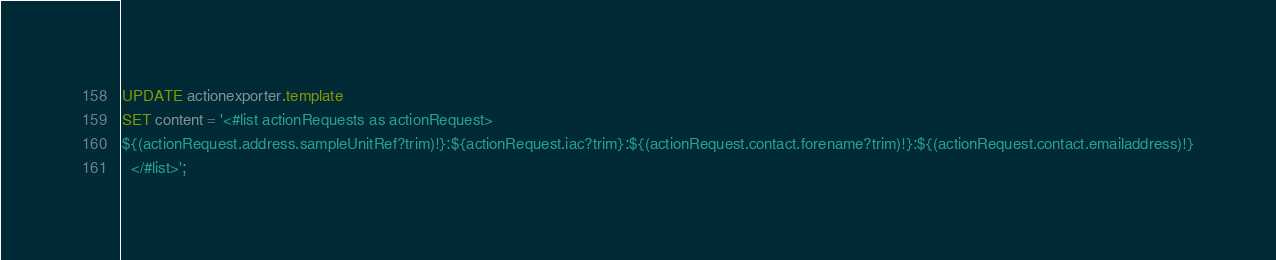Convert code to text. <code><loc_0><loc_0><loc_500><loc_500><_SQL_>UPDATE actionexporter.template
SET content = '<#list actionRequests as actionRequest>
${(actionRequest.address.sampleUnitRef?trim)!}:${actionRequest.iac?trim}:${(actionRequest.contact.forename?trim)!}:${(actionRequest.contact.emailaddress)!}
  </#list>';
</code> 